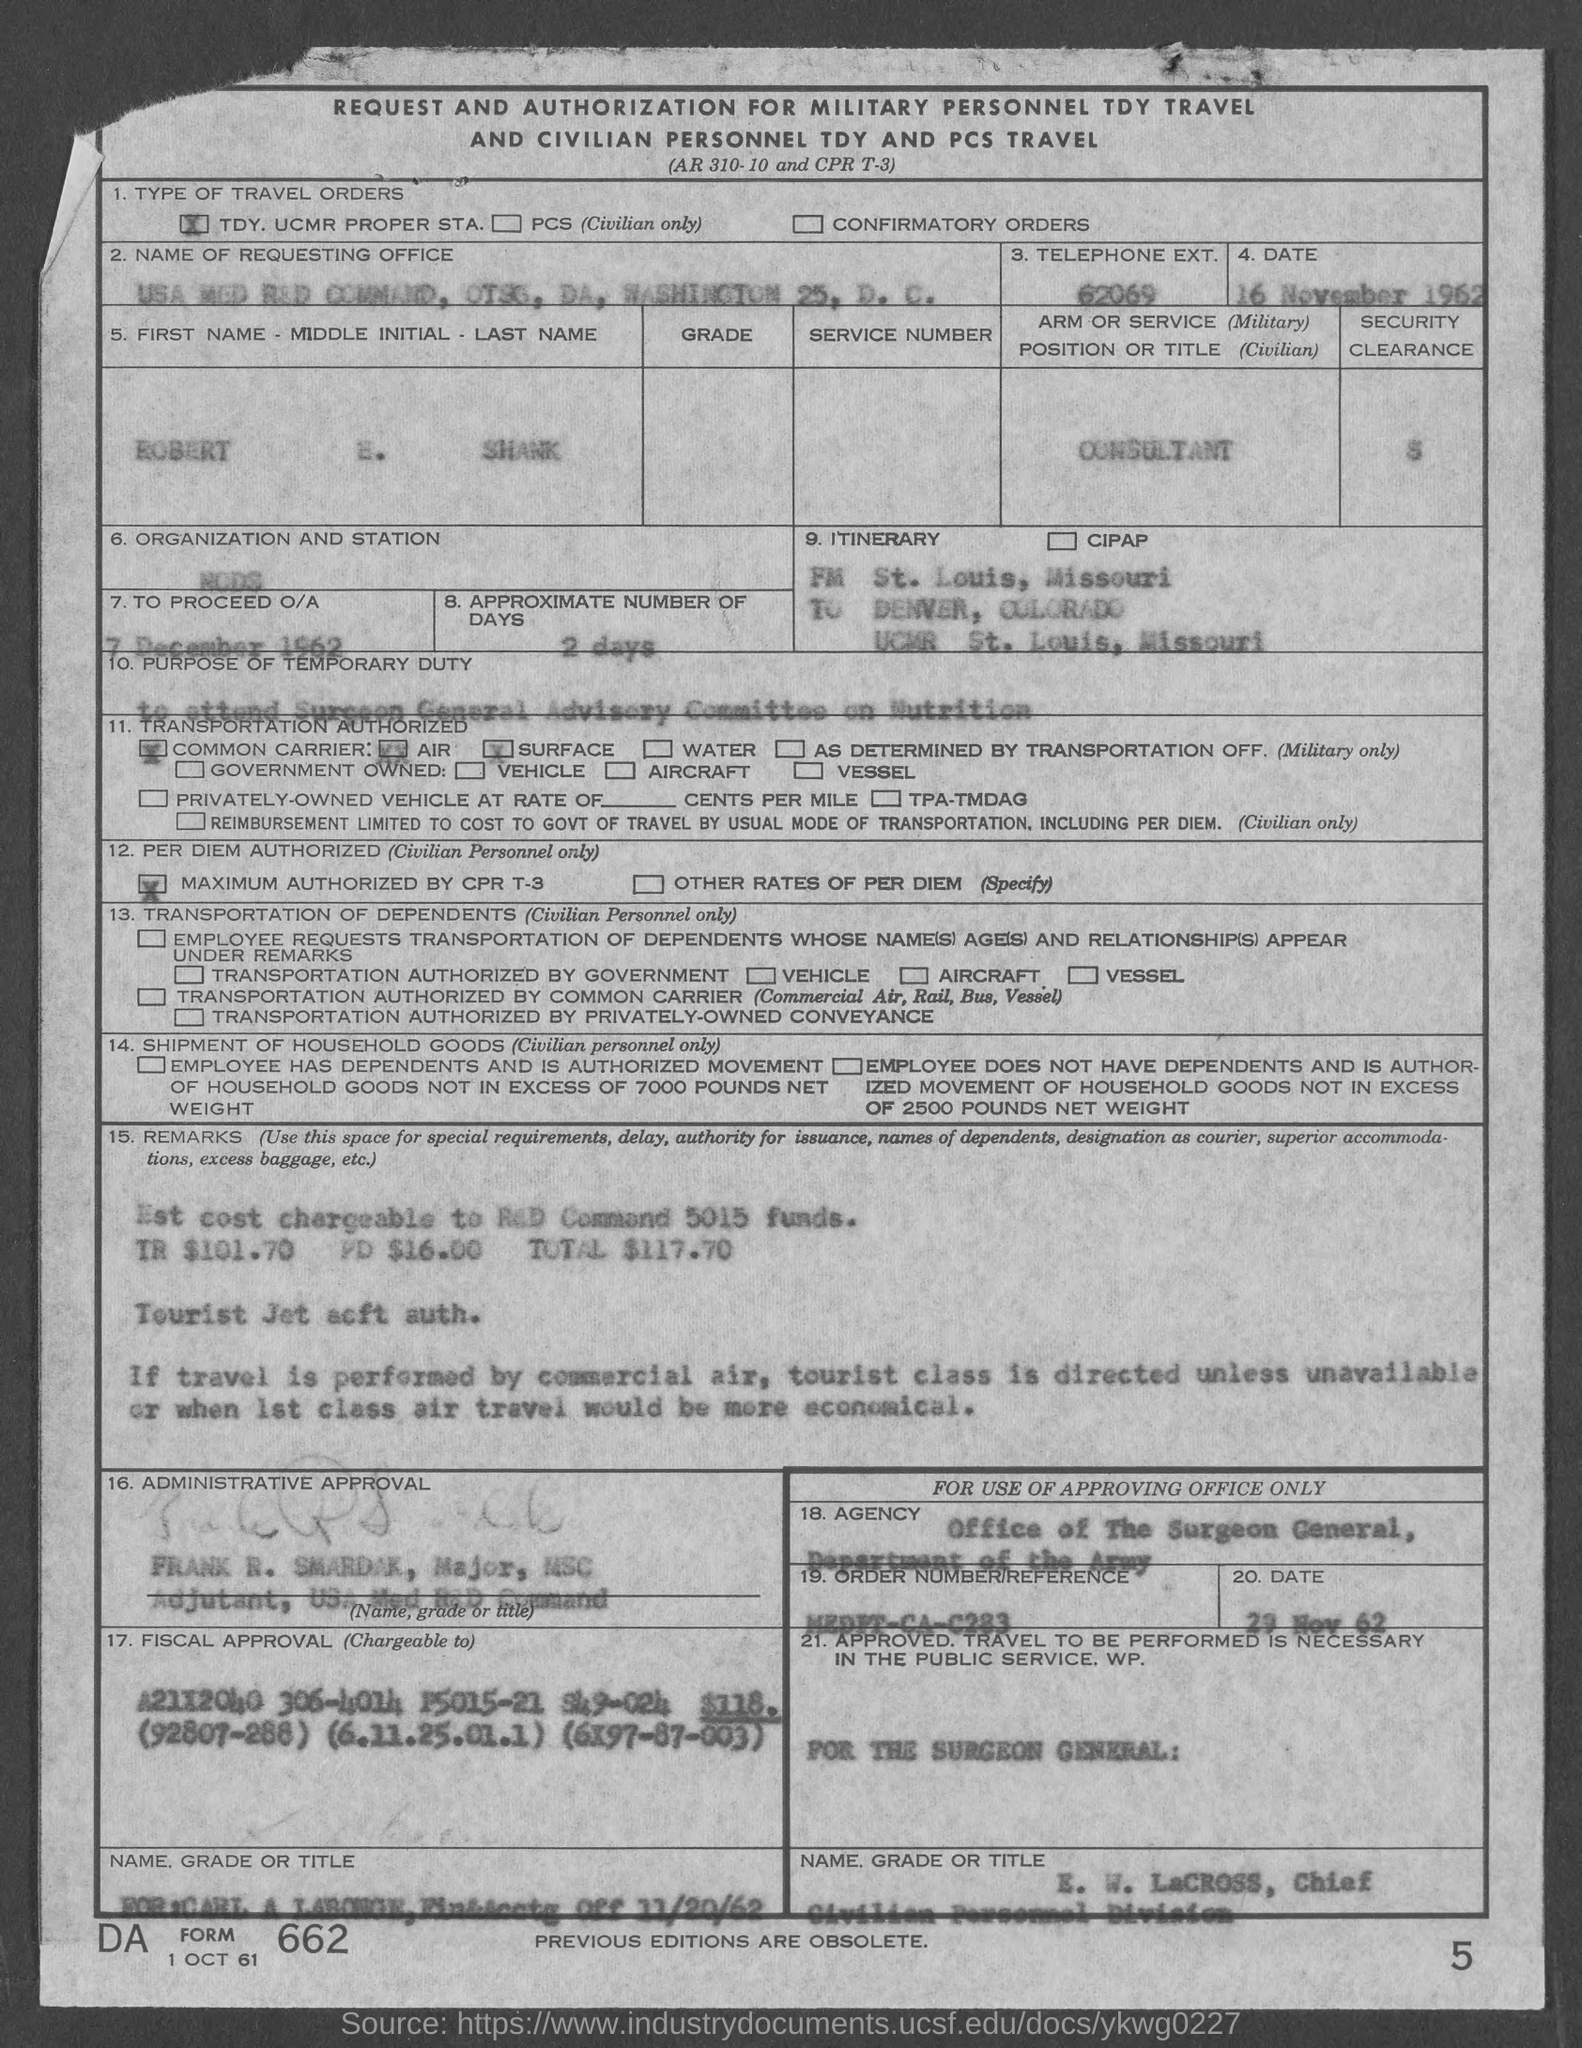Indicate a few pertinent items in this graphic. The telephone extension number is 62069. Approximately 2 days have passed. 